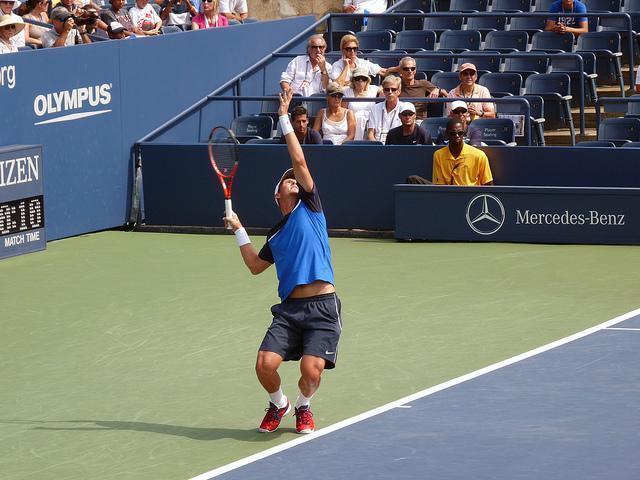How many people can you see?
Give a very brief answer. 3. How many toilets are in the room?
Give a very brief answer. 0. 